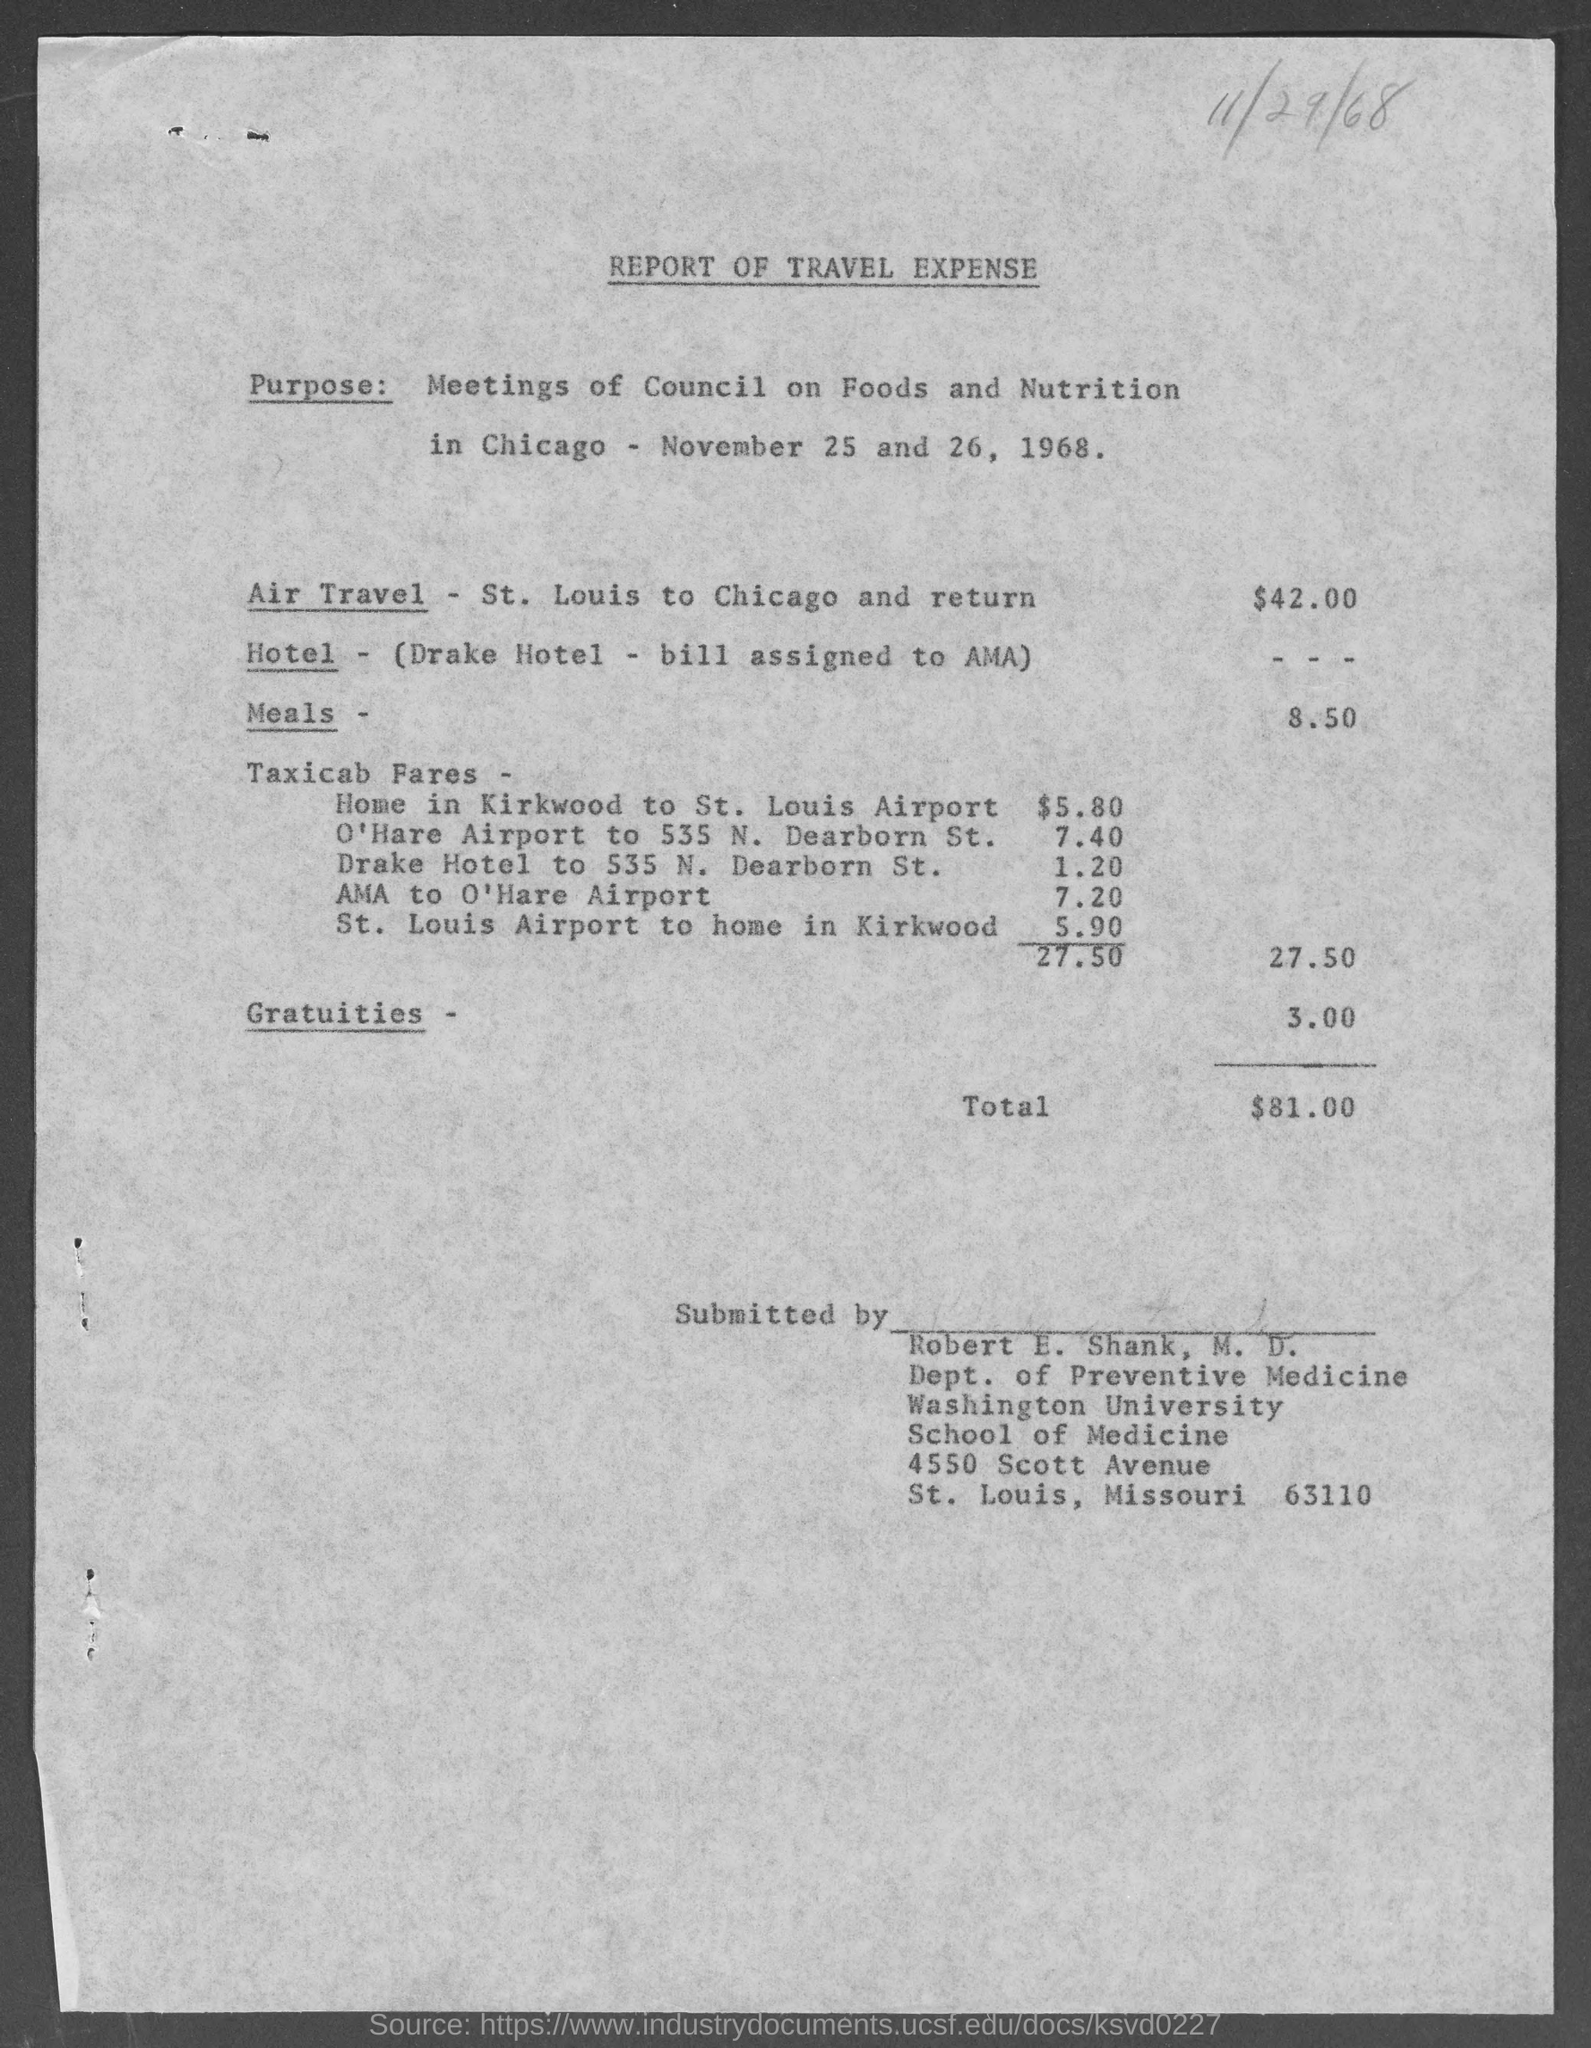Draw attention to some important aspects in this diagram. The total amount is $81.00. The report was submitted by Robert E. Shank, M.D. The street address of Washington University School of Medicine is located at 4550 Scott Avenue. 